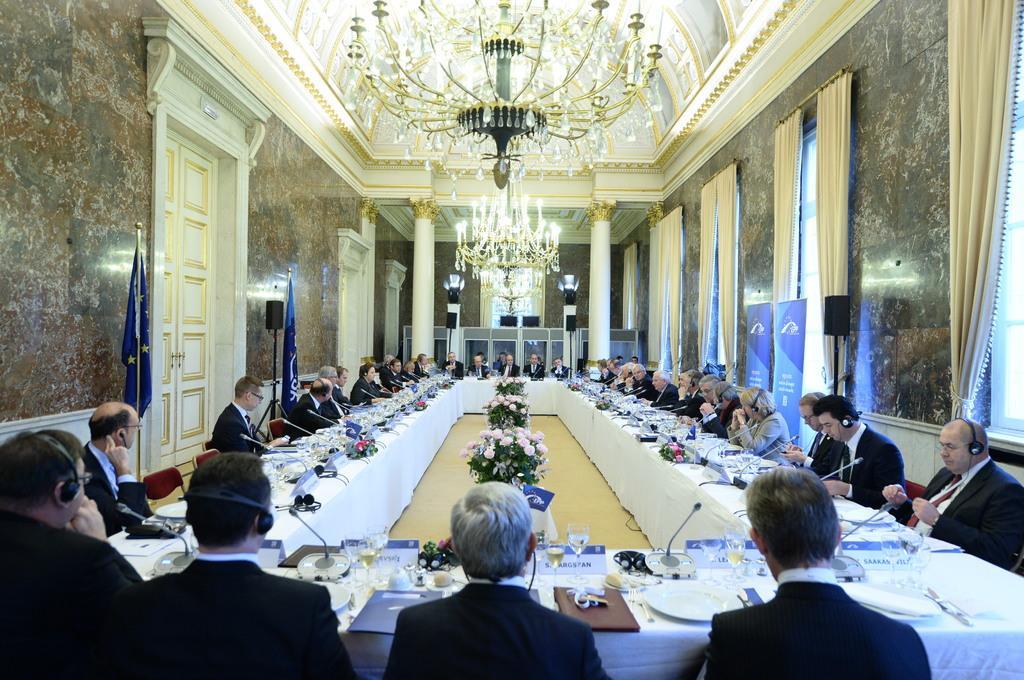Can you describe this image briefly? A meeting is going on. People are seated on the chairs. There are tables. In the center there are flowers. On the table there are glasses, microphones, windows, curtains, speakers,door and chandeliers on the top. 